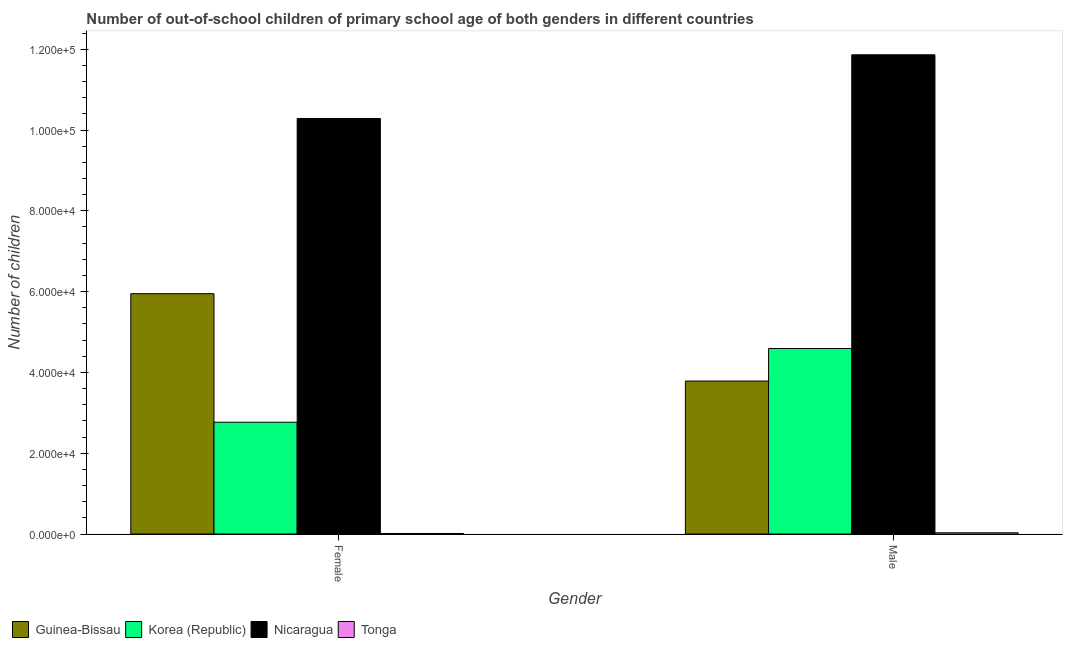How many different coloured bars are there?
Make the answer very short. 4. Are the number of bars per tick equal to the number of legend labels?
Your answer should be very brief. Yes. How many bars are there on the 2nd tick from the left?
Your answer should be compact. 4. What is the label of the 1st group of bars from the left?
Your answer should be very brief. Female. What is the number of female out-of-school students in Korea (Republic)?
Keep it short and to the point. 2.77e+04. Across all countries, what is the maximum number of male out-of-school students?
Provide a succinct answer. 1.19e+05. Across all countries, what is the minimum number of male out-of-school students?
Your answer should be compact. 304. In which country was the number of male out-of-school students maximum?
Your answer should be very brief. Nicaragua. In which country was the number of female out-of-school students minimum?
Offer a terse response. Tonga. What is the total number of female out-of-school students in the graph?
Give a very brief answer. 1.90e+05. What is the difference between the number of female out-of-school students in Nicaragua and that in Tonga?
Offer a very short reply. 1.03e+05. What is the difference between the number of female out-of-school students in Nicaragua and the number of male out-of-school students in Korea (Republic)?
Provide a succinct answer. 5.69e+04. What is the average number of male out-of-school students per country?
Provide a succinct answer. 5.07e+04. What is the difference between the number of female out-of-school students and number of male out-of-school students in Tonga?
Provide a short and direct response. -174. What is the ratio of the number of male out-of-school students in Nicaragua to that in Guinea-Bissau?
Your response must be concise. 3.13. What does the 2nd bar from the left in Female represents?
Your answer should be compact. Korea (Republic). What does the 1st bar from the right in Male represents?
Ensure brevity in your answer.  Tonga. Are all the bars in the graph horizontal?
Ensure brevity in your answer.  No. Are the values on the major ticks of Y-axis written in scientific E-notation?
Your answer should be very brief. Yes. Does the graph contain any zero values?
Make the answer very short. No. How are the legend labels stacked?
Provide a short and direct response. Horizontal. What is the title of the graph?
Offer a terse response. Number of out-of-school children of primary school age of both genders in different countries. What is the label or title of the X-axis?
Offer a terse response. Gender. What is the label or title of the Y-axis?
Keep it short and to the point. Number of children. What is the Number of children in Guinea-Bissau in Female?
Keep it short and to the point. 5.95e+04. What is the Number of children of Korea (Republic) in Female?
Make the answer very short. 2.77e+04. What is the Number of children in Nicaragua in Female?
Provide a succinct answer. 1.03e+05. What is the Number of children of Tonga in Female?
Your response must be concise. 130. What is the Number of children of Guinea-Bissau in Male?
Make the answer very short. 3.79e+04. What is the Number of children in Korea (Republic) in Male?
Make the answer very short. 4.59e+04. What is the Number of children in Nicaragua in Male?
Your answer should be compact. 1.19e+05. What is the Number of children of Tonga in Male?
Make the answer very short. 304. Across all Gender, what is the maximum Number of children in Guinea-Bissau?
Your answer should be very brief. 5.95e+04. Across all Gender, what is the maximum Number of children of Korea (Republic)?
Ensure brevity in your answer.  4.59e+04. Across all Gender, what is the maximum Number of children of Nicaragua?
Give a very brief answer. 1.19e+05. Across all Gender, what is the maximum Number of children in Tonga?
Make the answer very short. 304. Across all Gender, what is the minimum Number of children of Guinea-Bissau?
Give a very brief answer. 3.79e+04. Across all Gender, what is the minimum Number of children in Korea (Republic)?
Make the answer very short. 2.77e+04. Across all Gender, what is the minimum Number of children of Nicaragua?
Your answer should be very brief. 1.03e+05. Across all Gender, what is the minimum Number of children of Tonga?
Keep it short and to the point. 130. What is the total Number of children of Guinea-Bissau in the graph?
Your answer should be compact. 9.74e+04. What is the total Number of children of Korea (Republic) in the graph?
Provide a short and direct response. 7.36e+04. What is the total Number of children in Nicaragua in the graph?
Your answer should be compact. 2.21e+05. What is the total Number of children in Tonga in the graph?
Offer a terse response. 434. What is the difference between the Number of children in Guinea-Bissau in Female and that in Male?
Offer a terse response. 2.16e+04. What is the difference between the Number of children in Korea (Republic) in Female and that in Male?
Make the answer very short. -1.82e+04. What is the difference between the Number of children in Nicaragua in Female and that in Male?
Give a very brief answer. -1.58e+04. What is the difference between the Number of children in Tonga in Female and that in Male?
Make the answer very short. -174. What is the difference between the Number of children of Guinea-Bissau in Female and the Number of children of Korea (Republic) in Male?
Provide a short and direct response. 1.36e+04. What is the difference between the Number of children of Guinea-Bissau in Female and the Number of children of Nicaragua in Male?
Your response must be concise. -5.91e+04. What is the difference between the Number of children in Guinea-Bissau in Female and the Number of children in Tonga in Male?
Offer a terse response. 5.92e+04. What is the difference between the Number of children of Korea (Republic) in Female and the Number of children of Nicaragua in Male?
Offer a terse response. -9.10e+04. What is the difference between the Number of children of Korea (Republic) in Female and the Number of children of Tonga in Male?
Your answer should be compact. 2.74e+04. What is the difference between the Number of children of Nicaragua in Female and the Number of children of Tonga in Male?
Make the answer very short. 1.03e+05. What is the average Number of children of Guinea-Bissau per Gender?
Provide a short and direct response. 4.87e+04. What is the average Number of children in Korea (Republic) per Gender?
Your response must be concise. 3.68e+04. What is the average Number of children in Nicaragua per Gender?
Provide a short and direct response. 1.11e+05. What is the average Number of children of Tonga per Gender?
Give a very brief answer. 217. What is the difference between the Number of children of Guinea-Bissau and Number of children of Korea (Republic) in Female?
Offer a very short reply. 3.18e+04. What is the difference between the Number of children of Guinea-Bissau and Number of children of Nicaragua in Female?
Offer a very short reply. -4.34e+04. What is the difference between the Number of children of Guinea-Bissau and Number of children of Tonga in Female?
Offer a very short reply. 5.94e+04. What is the difference between the Number of children in Korea (Republic) and Number of children in Nicaragua in Female?
Provide a succinct answer. -7.52e+04. What is the difference between the Number of children in Korea (Republic) and Number of children in Tonga in Female?
Your answer should be compact. 2.75e+04. What is the difference between the Number of children of Nicaragua and Number of children of Tonga in Female?
Your answer should be very brief. 1.03e+05. What is the difference between the Number of children of Guinea-Bissau and Number of children of Korea (Republic) in Male?
Keep it short and to the point. -8050. What is the difference between the Number of children of Guinea-Bissau and Number of children of Nicaragua in Male?
Your response must be concise. -8.08e+04. What is the difference between the Number of children in Guinea-Bissau and Number of children in Tonga in Male?
Give a very brief answer. 3.76e+04. What is the difference between the Number of children of Korea (Republic) and Number of children of Nicaragua in Male?
Offer a terse response. -7.27e+04. What is the difference between the Number of children in Korea (Republic) and Number of children in Tonga in Male?
Your response must be concise. 4.56e+04. What is the difference between the Number of children in Nicaragua and Number of children in Tonga in Male?
Your answer should be compact. 1.18e+05. What is the ratio of the Number of children of Guinea-Bissau in Female to that in Male?
Your answer should be compact. 1.57. What is the ratio of the Number of children in Korea (Republic) in Female to that in Male?
Give a very brief answer. 0.6. What is the ratio of the Number of children in Nicaragua in Female to that in Male?
Make the answer very short. 0.87. What is the ratio of the Number of children in Tonga in Female to that in Male?
Offer a very short reply. 0.43. What is the difference between the highest and the second highest Number of children in Guinea-Bissau?
Your answer should be very brief. 2.16e+04. What is the difference between the highest and the second highest Number of children in Korea (Republic)?
Keep it short and to the point. 1.82e+04. What is the difference between the highest and the second highest Number of children in Nicaragua?
Ensure brevity in your answer.  1.58e+04. What is the difference between the highest and the second highest Number of children of Tonga?
Your answer should be very brief. 174. What is the difference between the highest and the lowest Number of children in Guinea-Bissau?
Your answer should be compact. 2.16e+04. What is the difference between the highest and the lowest Number of children in Korea (Republic)?
Give a very brief answer. 1.82e+04. What is the difference between the highest and the lowest Number of children of Nicaragua?
Offer a very short reply. 1.58e+04. What is the difference between the highest and the lowest Number of children in Tonga?
Make the answer very short. 174. 